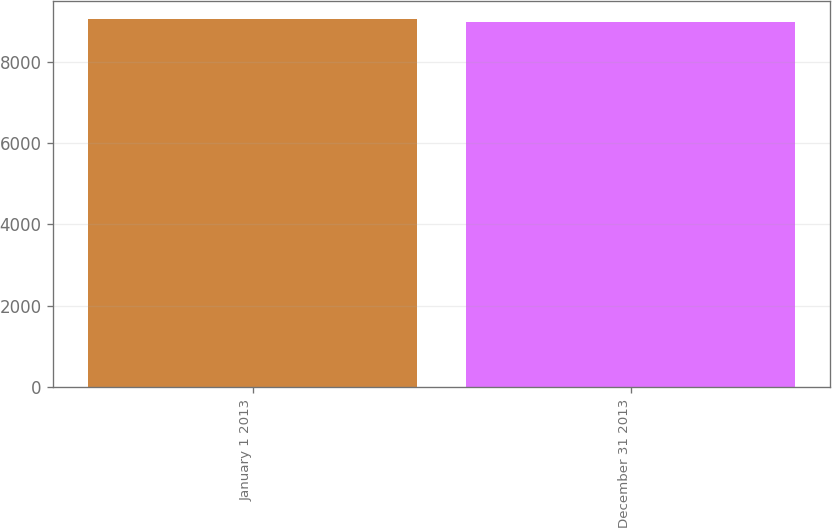Convert chart. <chart><loc_0><loc_0><loc_500><loc_500><bar_chart><fcel>January 1 2013<fcel>December 31 2013<nl><fcel>9049<fcel>8977.3<nl></chart> 